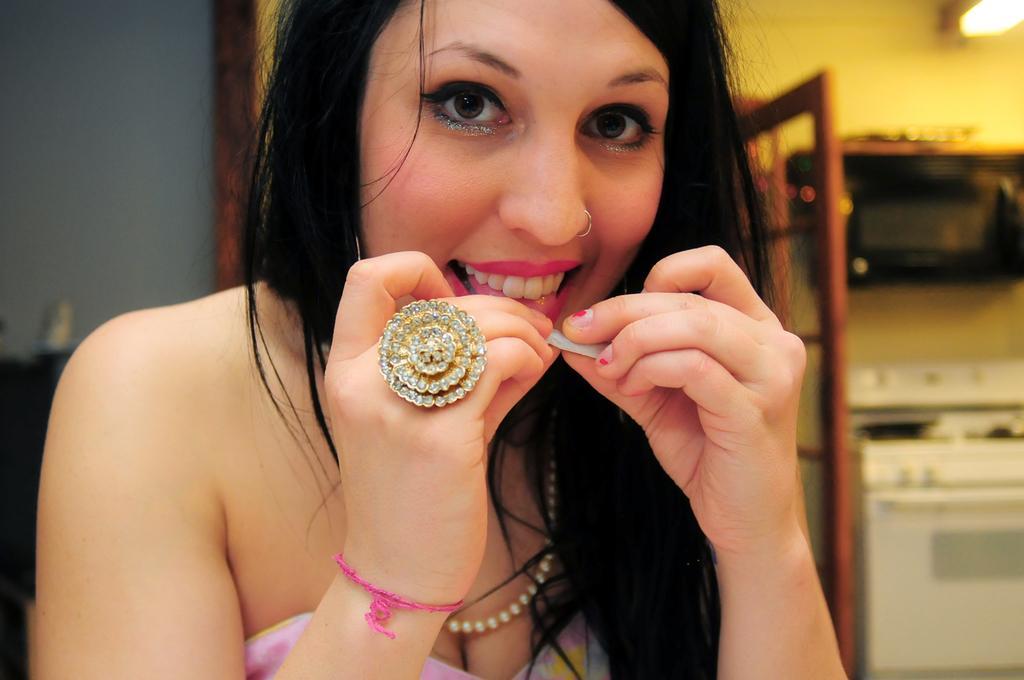Could you give a brief overview of what you see in this image? In this image we can see a lady and she is holding an object. There is a lamp on the wall at the right side of the image. There are few objects at the right side of the image. 